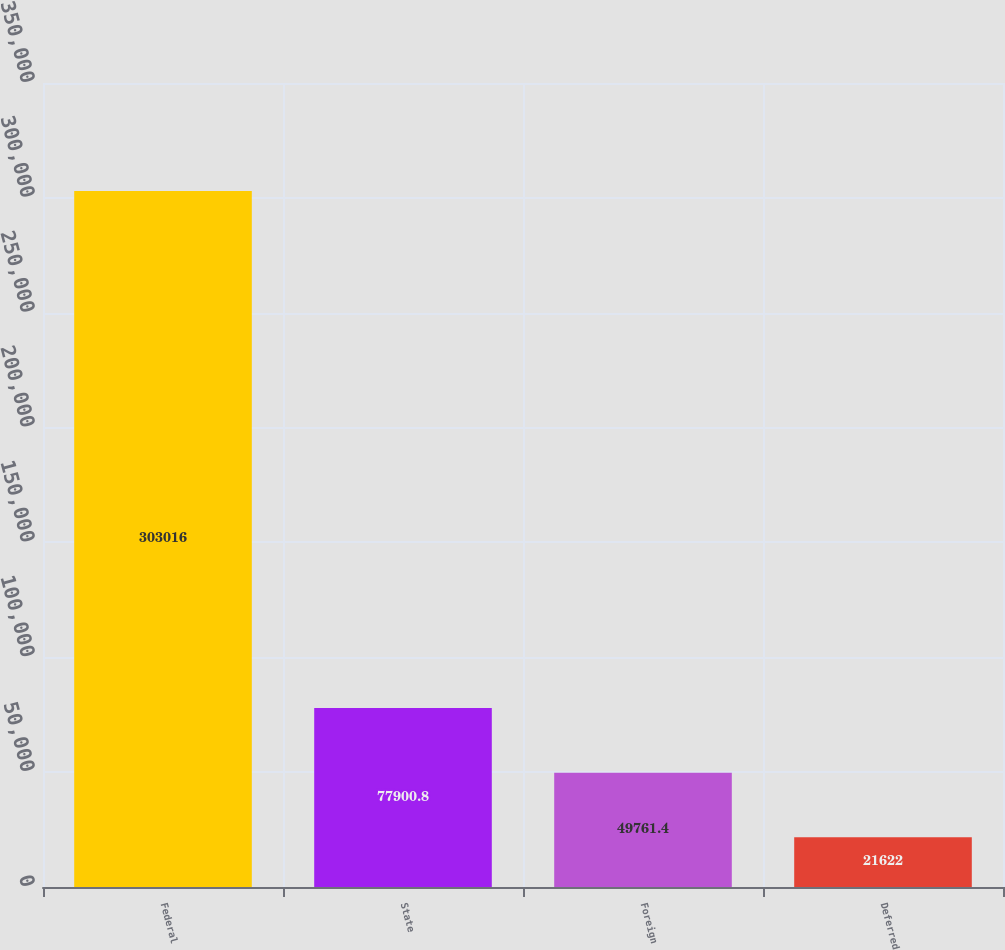Convert chart. <chart><loc_0><loc_0><loc_500><loc_500><bar_chart><fcel>Federal<fcel>State<fcel>Foreign<fcel>Deferred<nl><fcel>303016<fcel>77900.8<fcel>49761.4<fcel>21622<nl></chart> 